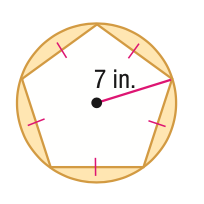Question: Find the area of the shaded region. Round to the nearest tenth.
Choices:
A. 7.5
B. 37.4
C. 130.6
D. 270.4
Answer with the letter. Answer: B 